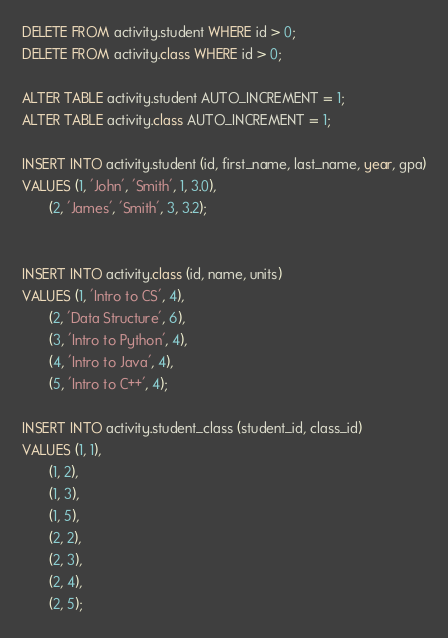Convert code to text. <code><loc_0><loc_0><loc_500><loc_500><_SQL_>DELETE FROM activity.student WHERE id > 0;
DELETE FROM activity.class WHERE id > 0;

ALTER TABLE activity.student AUTO_INCREMENT = 1;
ALTER TABLE activity.class AUTO_INCREMENT = 1;

INSERT INTO activity.student (id, first_name, last_name, year, gpa)
VALUES (1, 'John', 'Smith', 1, 3.0),
       (2, 'James', 'Smith', 3, 3.2);


INSERT INTO activity.class (id, name, units)
VALUES (1, 'Intro to CS', 4),
       (2, 'Data Structure', 6),
       (3, 'Intro to Python', 4),
       (4, 'Intro to Java', 4),
       (5, 'Intro to C++', 4);

INSERT INTO activity.student_class (student_id, class_id)
VALUES (1, 1),
       (1, 2),
       (1, 3),
       (1, 5),
       (2, 2),
       (2, 3),
       (2, 4),
       (2, 5);
</code> 